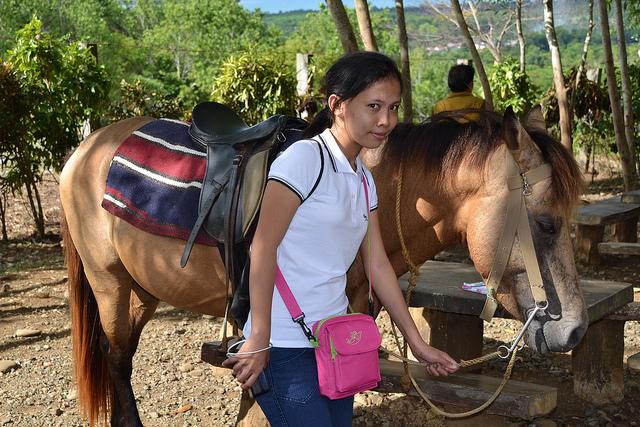Is the horse wearing a saddle?
Give a very brief answer. Yes. What animal is the girl by?
Concise answer only. Horse. Is the pony's mane long?
Keep it brief. No. What color is her purse?
Give a very brief answer. Pink. Is this a park?
Short answer required. Yes. What is the horse walking toward?
Be succinct. Food. Is the little girl wearing a sweater?
Quick response, please. No. 